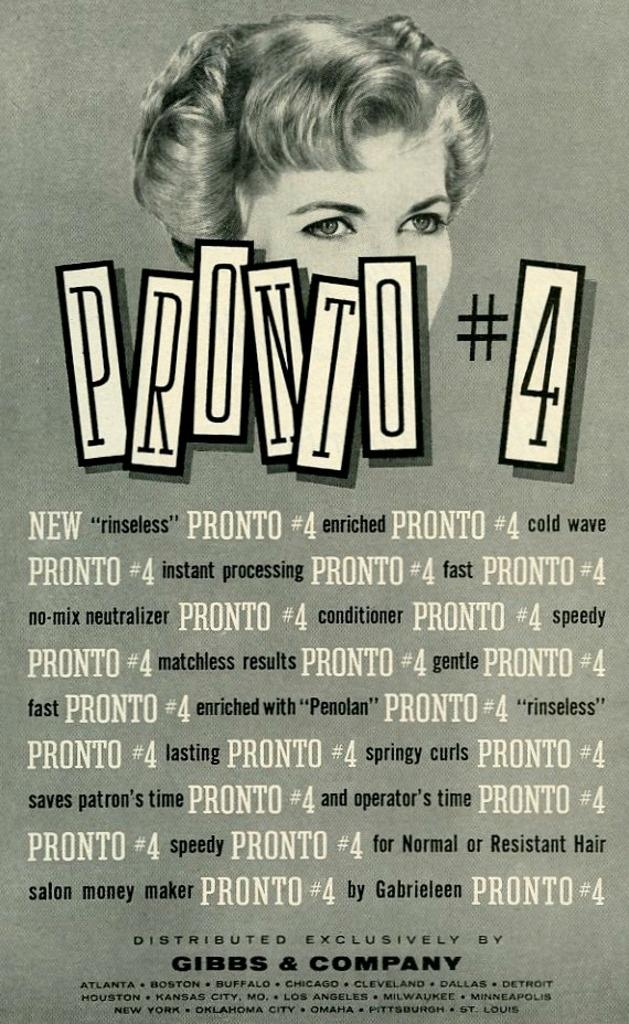<image>
Render a clear and concise summary of the photo. A Gibbs & Company poster featuring Pronto # 4 with a woman pictured behind the title. 